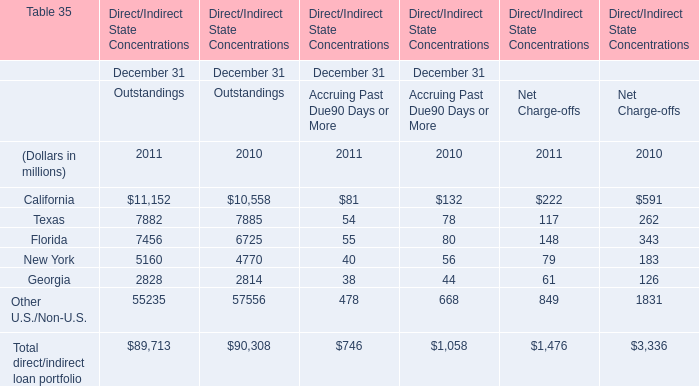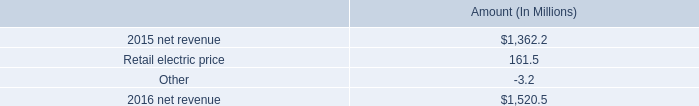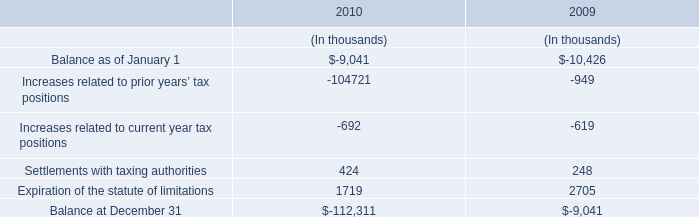What's the average of California in Outstandings in 2011 and 2010? (in millions) 
Computations: ((11152 + 10558) / 2)
Answer: 10855.0. 